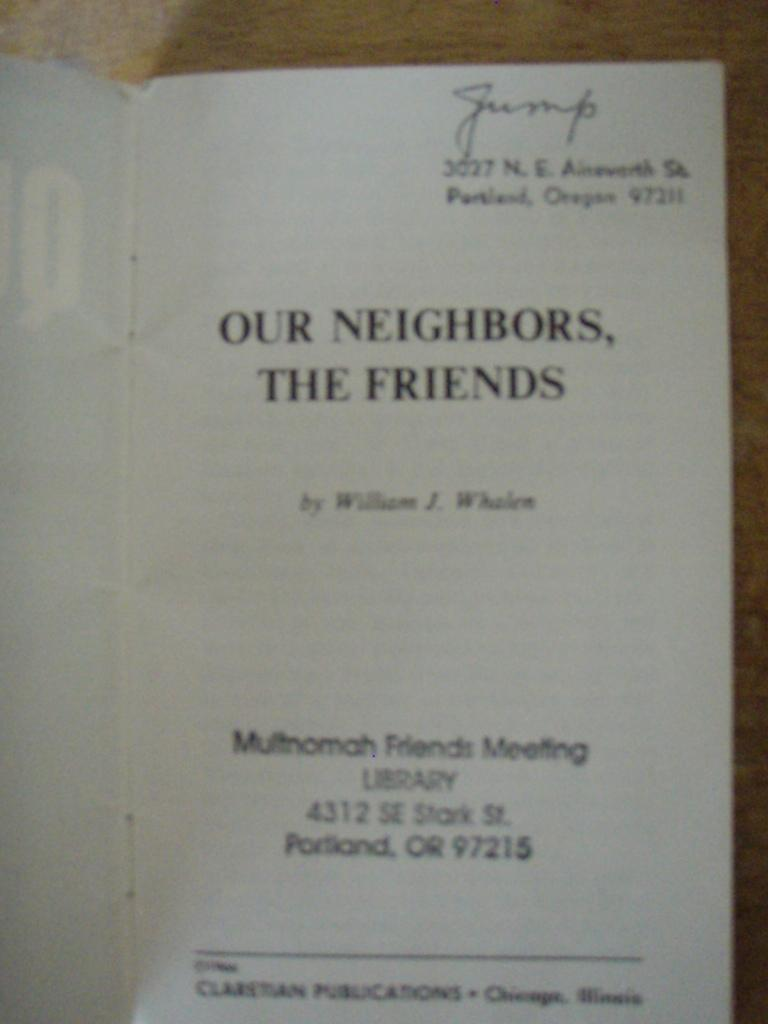<image>
Write a terse but informative summary of the picture. A book opened to a title page reading Our Neighbors, the Friends. 